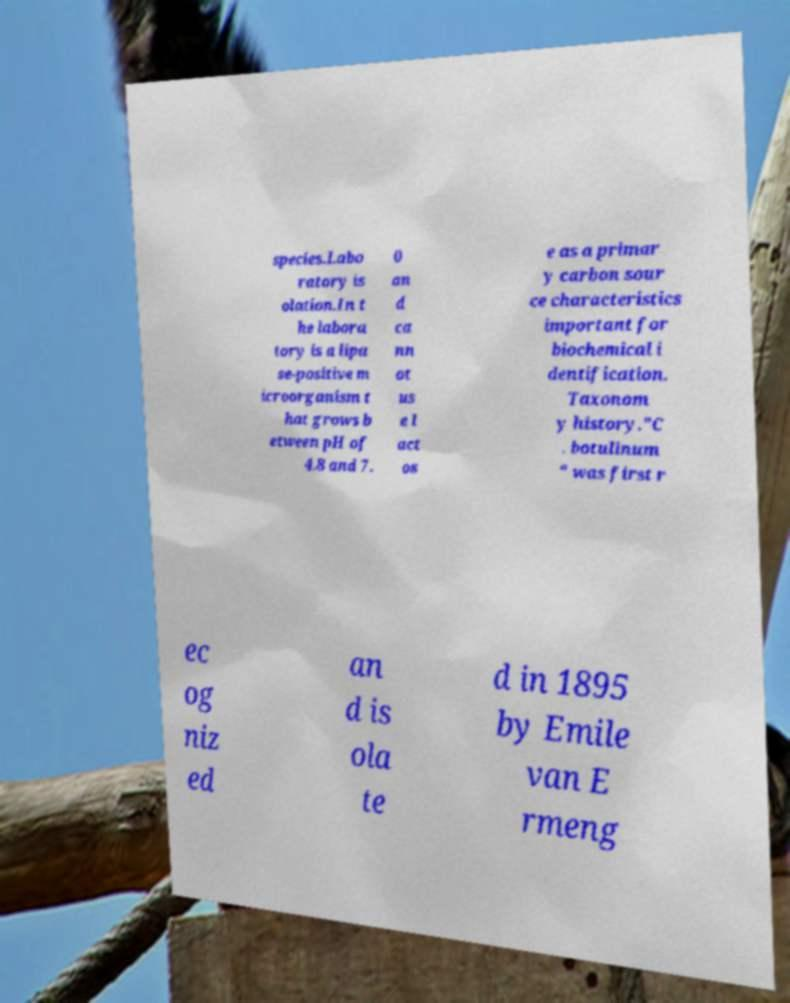Can you read and provide the text displayed in the image?This photo seems to have some interesting text. Can you extract and type it out for me? species.Labo ratory is olation.In t he labora tory is a lipa se-positive m icroorganism t hat grows b etween pH of 4.8 and 7. 0 an d ca nn ot us e l act os e as a primar y carbon sour ce characteristics important for biochemical i dentification. Taxonom y history."C . botulinum " was first r ec og niz ed an d is ola te d in 1895 by Emile van E rmeng 